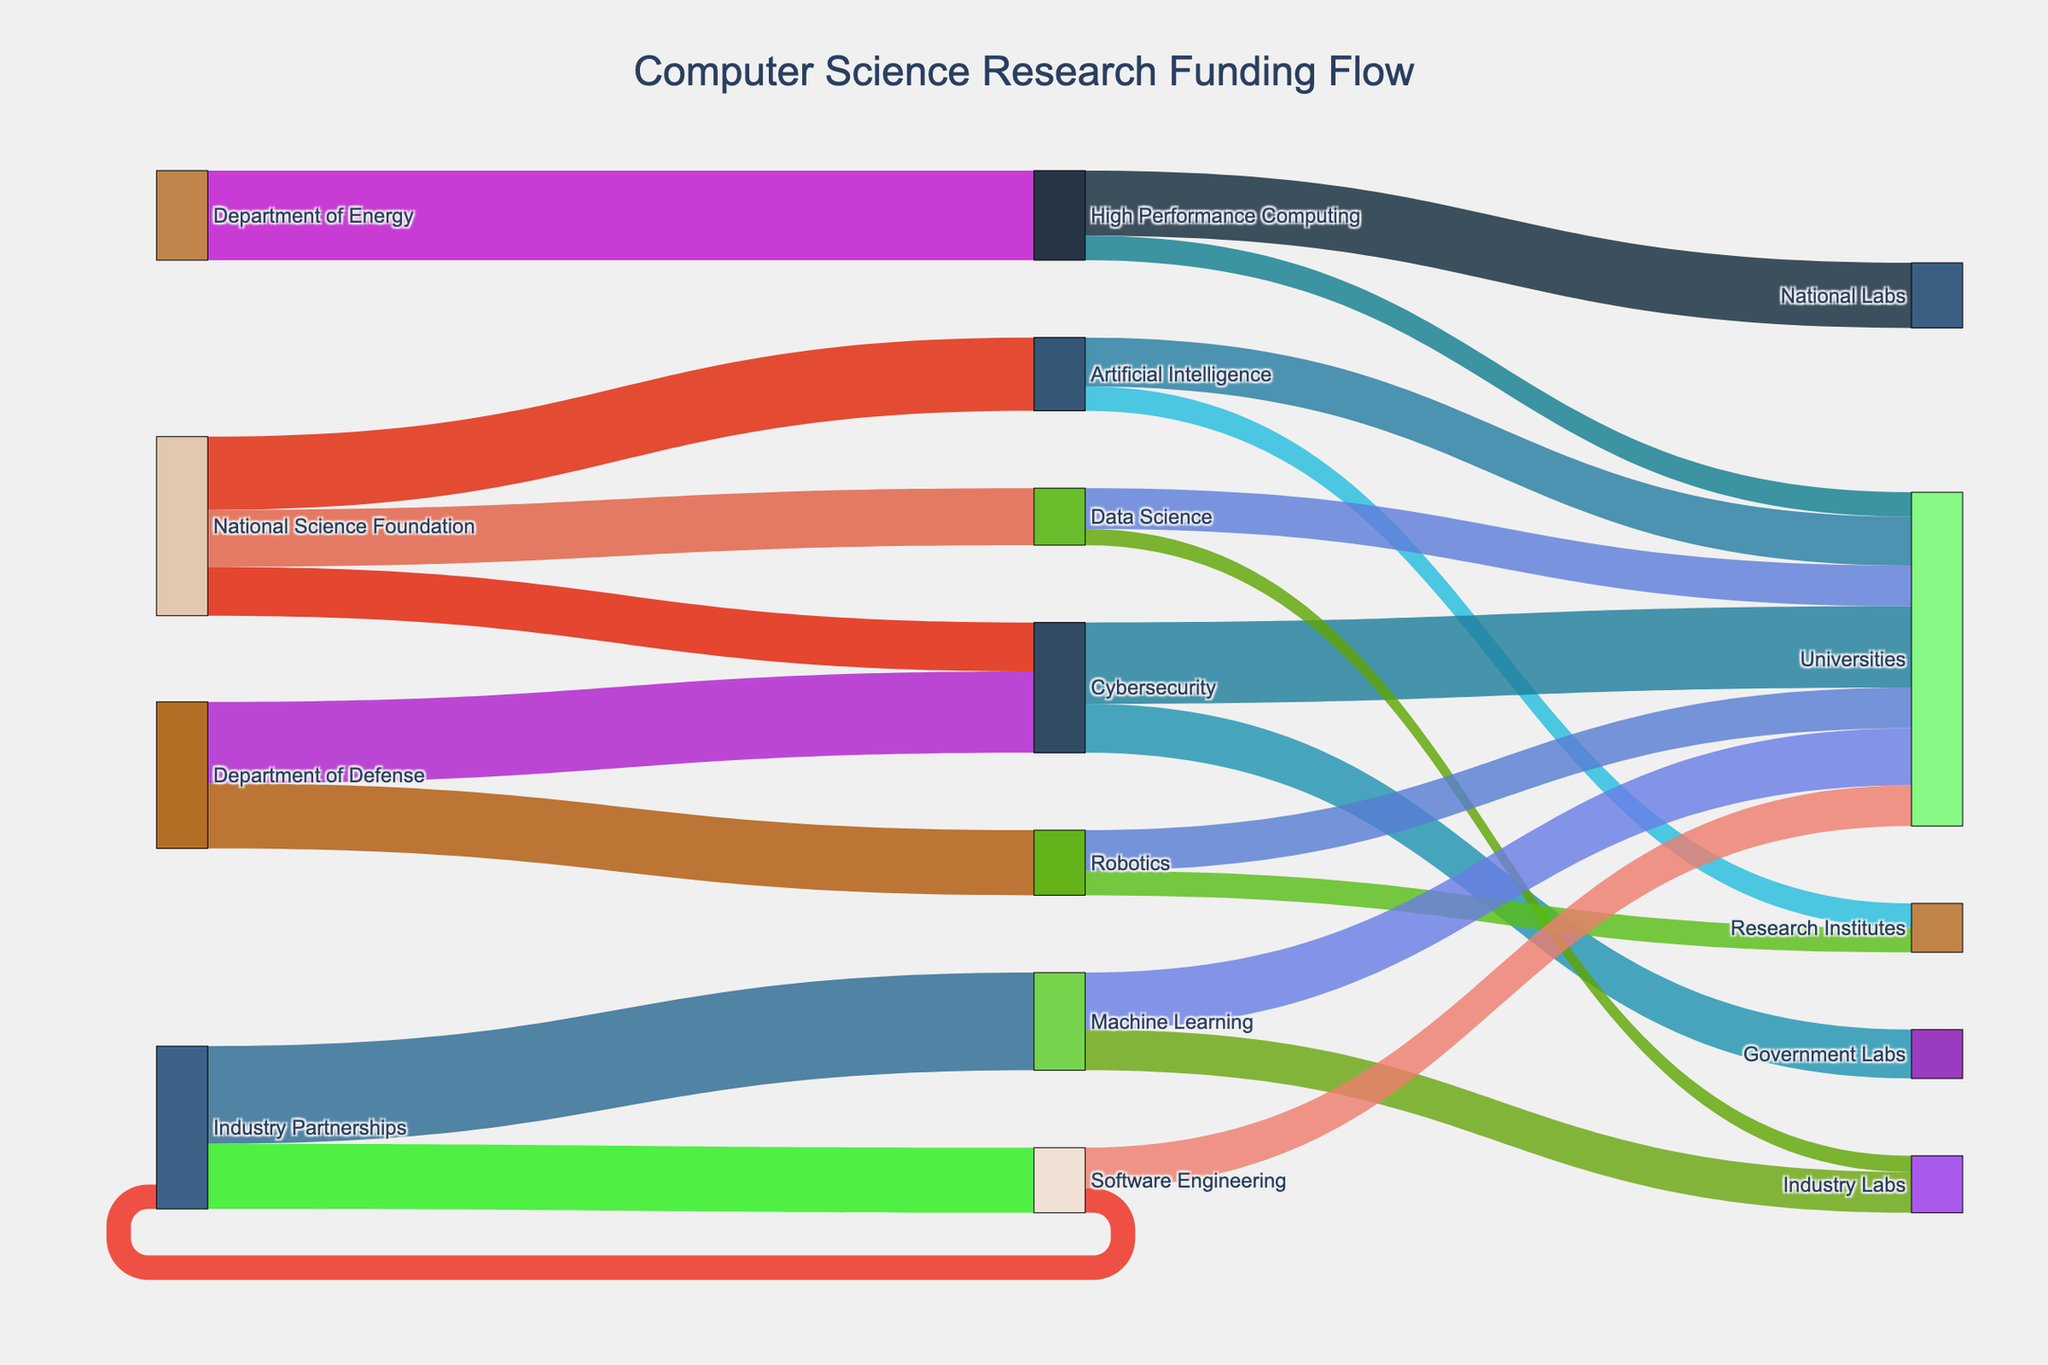What is the main title of the chart? The main title of the chart is usually found at the top and indicates the overall topic or purpose of the visualization.
Answer: Computer Science Research Funding Flow Which funding source provides the most funding to Cybersecurity? By tracing the lines from different funding sources to the Cybersecurity node, you can identify that the Department of Defense provides more funding compared to the National Science Foundation.
Answer: Department of Defense How much total funding does the National Science Foundation allocate to different specializations? Sum the values of all flows coming from the National Science Foundation: 45 (AI) + 30 (Cybersecurity) + 35 (Data Science) = 110
Answer: 110 Which specialization receives funding from the most different sources? By verifying which specialization has incoming flows from the greatest number of distinct funding sources, you'll see that Cybersecurity receives funding from both the National Science Foundation and Department of Defense.
Answer: Cybersecurity Between Artificial Intelligence and Cybersecurity, which one receives more total funding? Add up the total funding received by each specialization. AI: 45 from National Science Foundation. Cybersecurity: 30 from National Science Foundation and 50 from Department of Defense = 80. Compare the totals.
Answer: Cybersecurity What is the highest single amount of funding any specialization receives from a single source? Examine the flows from each source to the specializations and identify the maximum single value. The highest value is 60 to Machine Learning from Industry Partnerships.
Answer: 60 Which specialization has the most diverse allocation in terms of receiving institutions (Universities, Research Institutes, etc.)? Look at the number of different receiving institutions for each specialization. Artificial Intelligence funds Universities and Research Institutes, and Cybersecurity also funds Universities and Government Labs. Both have equal diversity.
Answer: Artificial Intelligence/Cybersecurity How many different institutions are involved in receiving funding for High Performance Computing? Trace the arrows from High Performance Computing and count the different types of receiving institutions. It includes National Labs and Universities.
Answer: 2 Comparing the total funding going to Universities and Research Institutes from all specializations, which one receives more? Sum up all the flows going to Universities and Research Institutes. Universities receive: 30 (AI) + 50 (Cyber) + 25 (Data Science) + 25 (Robotics) + 15 (HPC) + 35 (ML) + 25 (SE) = 205. Research Institutes receive: 15 (AI) + 15 (Robotics) = 30.
Answer: Universities Which specialization receives the least total funding? Sum the total funding for each specialization and find the minimum. Data Science receives 35 (NSF) = 35 and Software Engineering receives 40 (Industry) = 40; Data Science receives less.
Answer: Data Science 